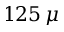Convert formula to latex. <formula><loc_0><loc_0><loc_500><loc_500>1 2 5 \, \mu</formula> 